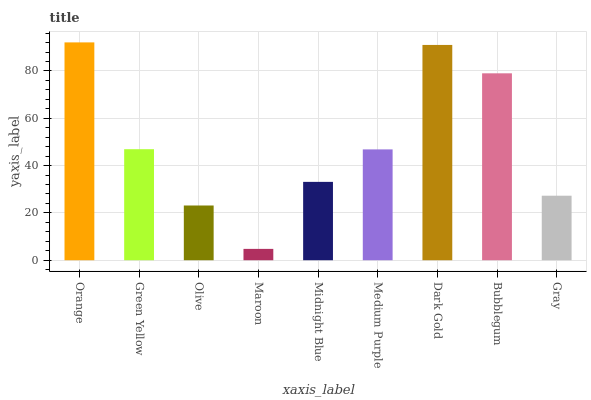Is Green Yellow the minimum?
Answer yes or no. No. Is Green Yellow the maximum?
Answer yes or no. No. Is Orange greater than Green Yellow?
Answer yes or no. Yes. Is Green Yellow less than Orange?
Answer yes or no. Yes. Is Green Yellow greater than Orange?
Answer yes or no. No. Is Orange less than Green Yellow?
Answer yes or no. No. Is Medium Purple the high median?
Answer yes or no. Yes. Is Medium Purple the low median?
Answer yes or no. Yes. Is Orange the high median?
Answer yes or no. No. Is Dark Gold the low median?
Answer yes or no. No. 